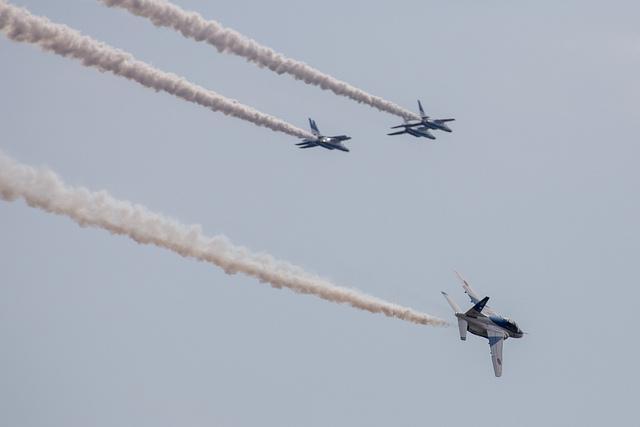How many planes are in the picture?
Give a very brief answer. 4. 